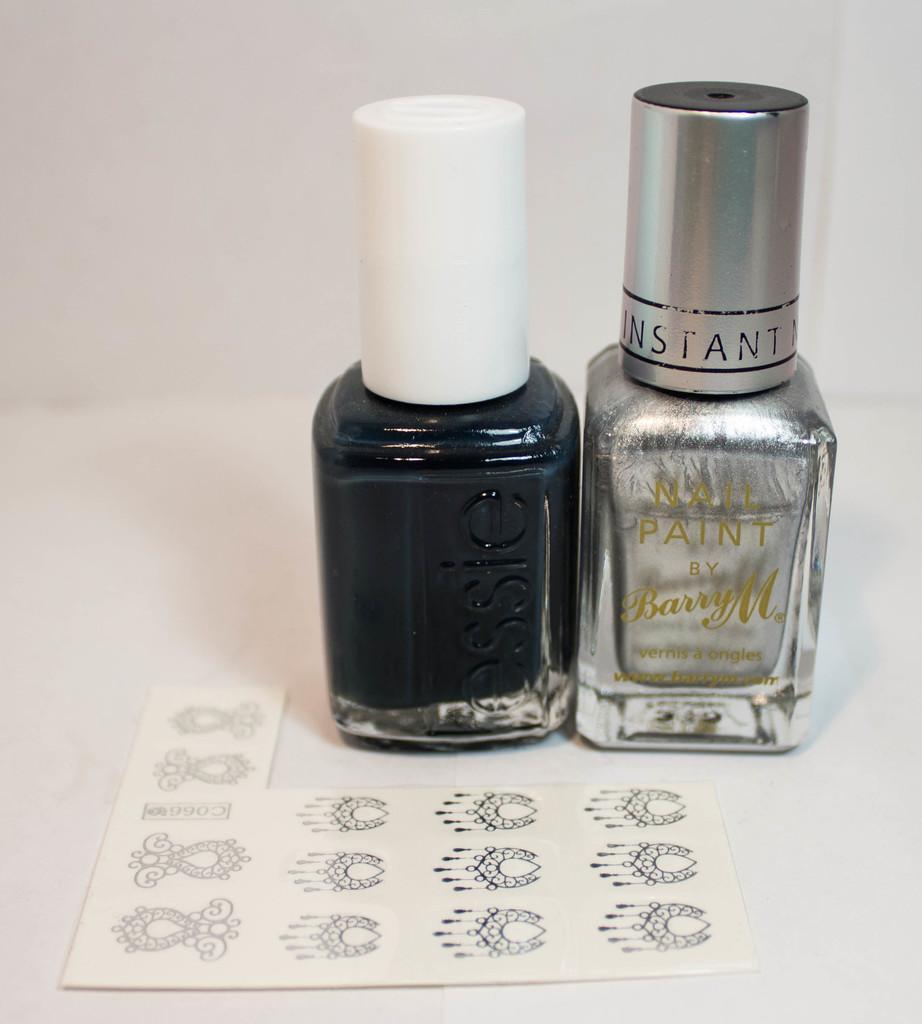Could you give a brief overview of what you see in this image? These are the two nail paint bottles. 